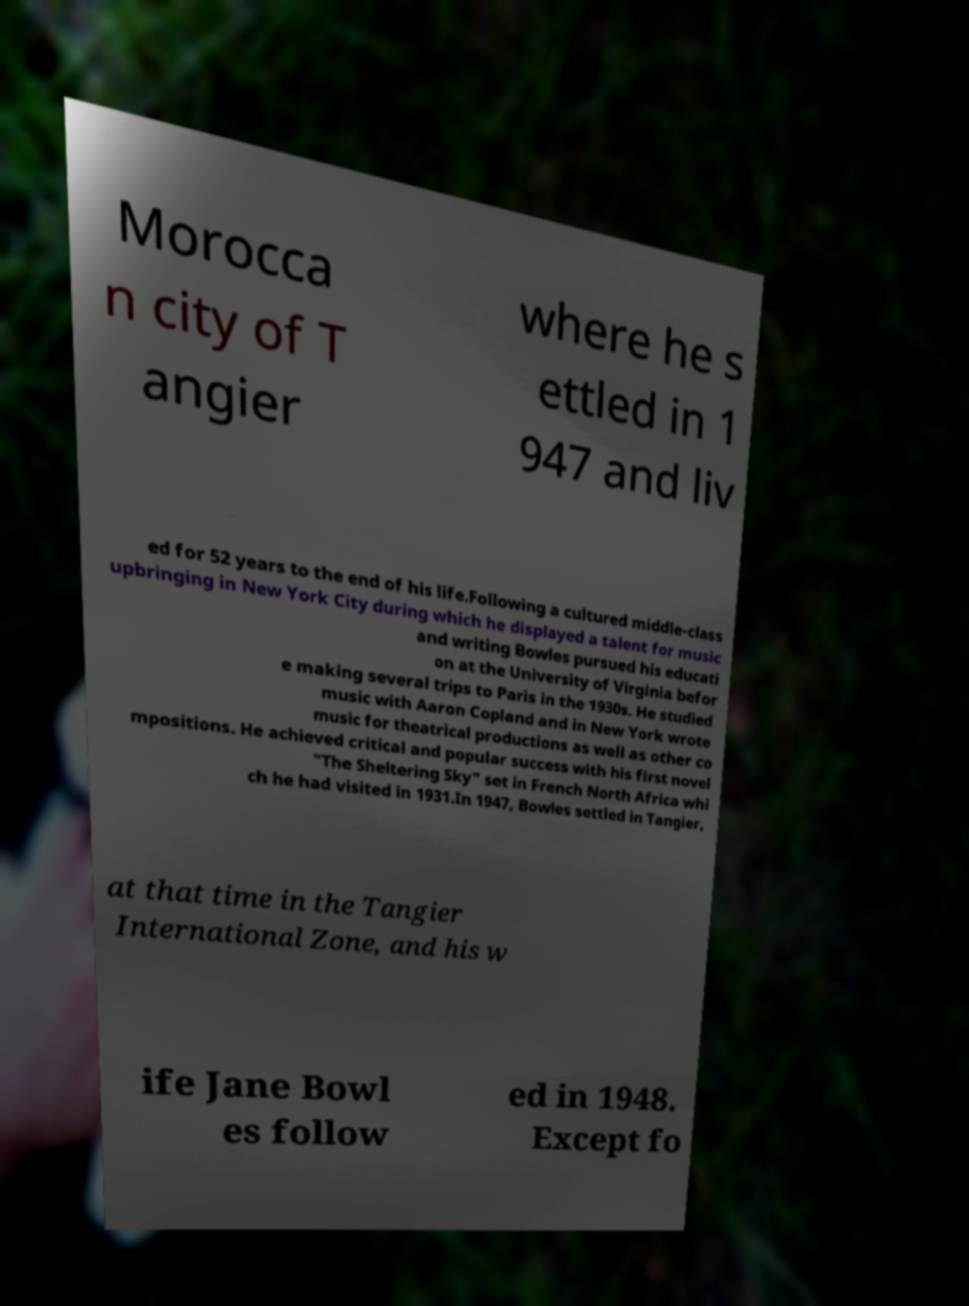Could you assist in decoding the text presented in this image and type it out clearly? Morocca n city of T angier where he s ettled in 1 947 and liv ed for 52 years to the end of his life.Following a cultured middle-class upbringing in New York City during which he displayed a talent for music and writing Bowles pursued his educati on at the University of Virginia befor e making several trips to Paris in the 1930s. He studied music with Aaron Copland and in New York wrote music for theatrical productions as well as other co mpositions. He achieved critical and popular success with his first novel "The Sheltering Sky" set in French North Africa whi ch he had visited in 1931.In 1947, Bowles settled in Tangier, at that time in the Tangier International Zone, and his w ife Jane Bowl es follow ed in 1948. Except fo 